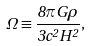<formula> <loc_0><loc_0><loc_500><loc_500>\Omega \equiv \frac { 8 \pi G \rho } { 3 c ^ { 2 } H ^ { 2 } } ,</formula> 